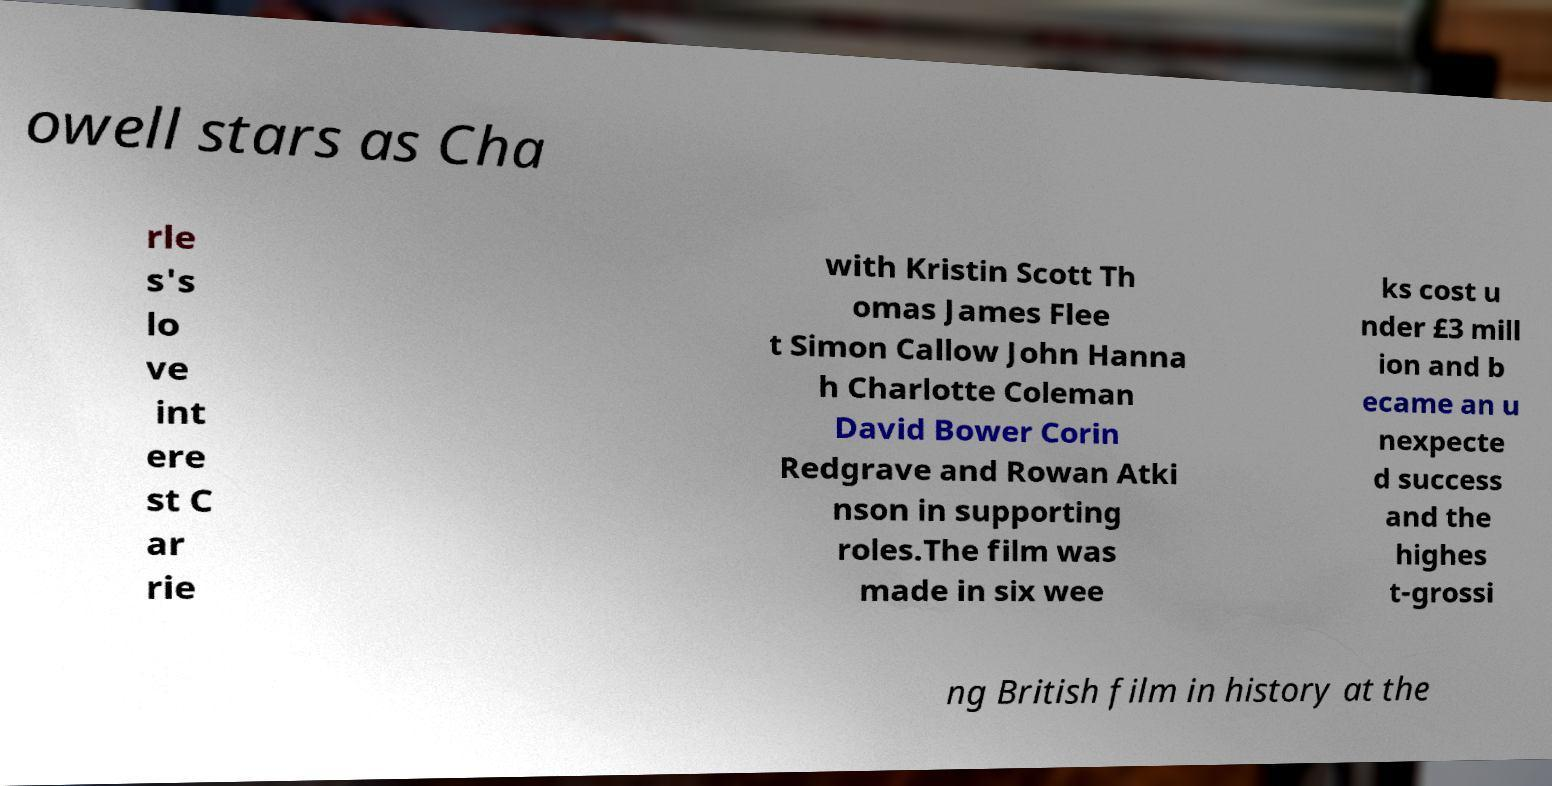Can you accurately transcribe the text from the provided image for me? owell stars as Cha rle s's lo ve int ere st C ar rie with Kristin Scott Th omas James Flee t Simon Callow John Hanna h Charlotte Coleman David Bower Corin Redgrave and Rowan Atki nson in supporting roles.The film was made in six wee ks cost u nder £3 mill ion and b ecame an u nexpecte d success and the highes t-grossi ng British film in history at the 